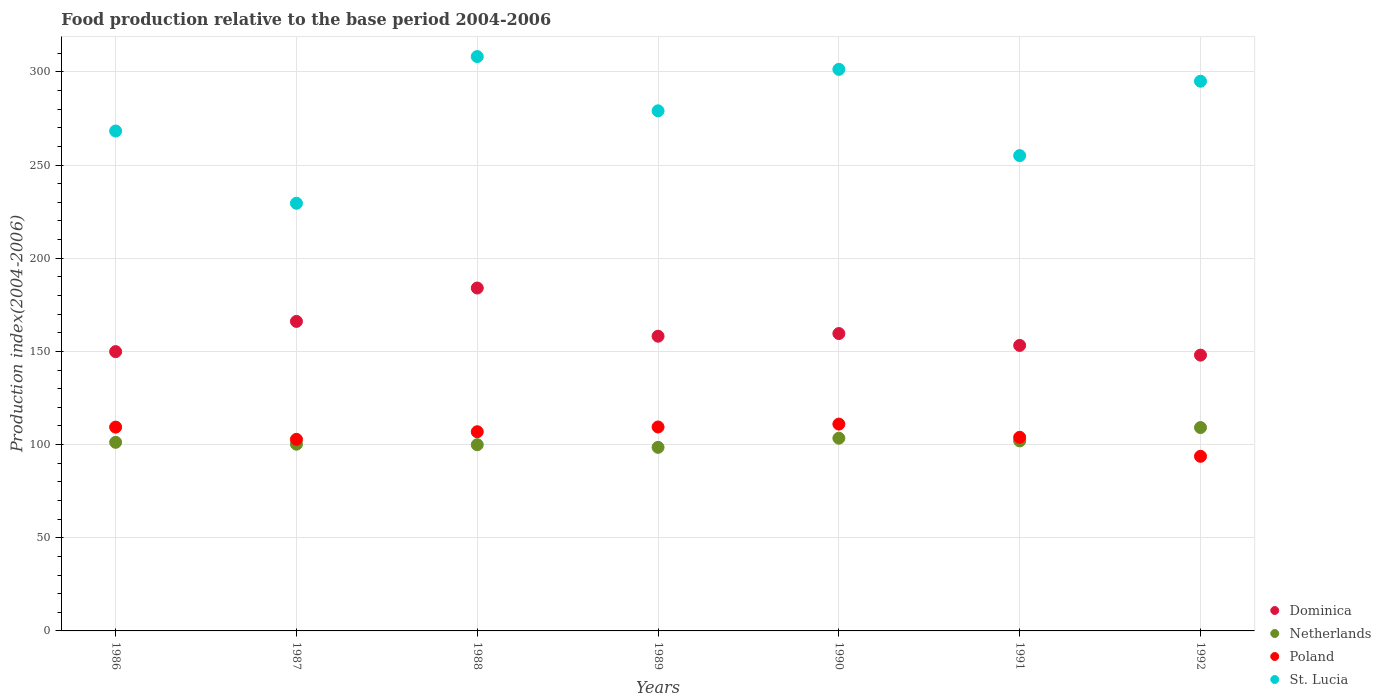How many different coloured dotlines are there?
Ensure brevity in your answer.  4. Is the number of dotlines equal to the number of legend labels?
Ensure brevity in your answer.  Yes. What is the food production index in Poland in 1992?
Offer a terse response. 93.71. Across all years, what is the maximum food production index in Poland?
Your answer should be very brief. 111. Across all years, what is the minimum food production index in Poland?
Offer a very short reply. 93.71. In which year was the food production index in Poland maximum?
Give a very brief answer. 1990. What is the total food production index in Netherlands in the graph?
Provide a succinct answer. 714.45. What is the difference between the food production index in Netherlands in 1989 and that in 1990?
Provide a succinct answer. -4.9. What is the difference between the food production index in Dominica in 1988 and the food production index in Poland in 1989?
Your answer should be very brief. 74.58. What is the average food production index in Netherlands per year?
Provide a short and direct response. 102.06. In the year 1986, what is the difference between the food production index in Poland and food production index in St. Lucia?
Your response must be concise. -158.92. In how many years, is the food production index in Dominica greater than 110?
Your answer should be very brief. 7. What is the ratio of the food production index in Poland in 1989 to that in 1991?
Offer a terse response. 1.05. Is the difference between the food production index in Poland in 1986 and 1988 greater than the difference between the food production index in St. Lucia in 1986 and 1988?
Give a very brief answer. Yes. What is the difference between the highest and the second highest food production index in Dominica?
Offer a terse response. 17.92. What is the difference between the highest and the lowest food production index in Dominica?
Your answer should be compact. 36.01. In how many years, is the food production index in Dominica greater than the average food production index in Dominica taken over all years?
Provide a short and direct response. 2. Is the sum of the food production index in St. Lucia in 1987 and 1991 greater than the maximum food production index in Poland across all years?
Ensure brevity in your answer.  Yes. Is it the case that in every year, the sum of the food production index in Poland and food production index in St. Lucia  is greater than the sum of food production index in Dominica and food production index in Netherlands?
Ensure brevity in your answer.  No. Is the food production index in Dominica strictly greater than the food production index in Netherlands over the years?
Offer a terse response. Yes. Is the food production index in Dominica strictly less than the food production index in St. Lucia over the years?
Your answer should be very brief. Yes. Does the graph contain grids?
Offer a very short reply. Yes. What is the title of the graph?
Provide a succinct answer. Food production relative to the base period 2004-2006. What is the label or title of the X-axis?
Keep it short and to the point. Years. What is the label or title of the Y-axis?
Your response must be concise. Production index(2004-2006). What is the Production index(2004-2006) in Dominica in 1986?
Your response must be concise. 149.89. What is the Production index(2004-2006) in Netherlands in 1986?
Your response must be concise. 101.22. What is the Production index(2004-2006) in Poland in 1986?
Keep it short and to the point. 109.38. What is the Production index(2004-2006) in St. Lucia in 1986?
Your answer should be very brief. 268.3. What is the Production index(2004-2006) of Dominica in 1987?
Your answer should be very brief. 166.11. What is the Production index(2004-2006) of Netherlands in 1987?
Offer a very short reply. 100.22. What is the Production index(2004-2006) of Poland in 1987?
Your response must be concise. 102.81. What is the Production index(2004-2006) in St. Lucia in 1987?
Provide a succinct answer. 229.51. What is the Production index(2004-2006) of Dominica in 1988?
Make the answer very short. 184.03. What is the Production index(2004-2006) in Netherlands in 1988?
Offer a terse response. 99.93. What is the Production index(2004-2006) of Poland in 1988?
Provide a succinct answer. 106.9. What is the Production index(2004-2006) of St. Lucia in 1988?
Your response must be concise. 308.25. What is the Production index(2004-2006) in Dominica in 1989?
Keep it short and to the point. 158.17. What is the Production index(2004-2006) in Netherlands in 1989?
Make the answer very short. 98.53. What is the Production index(2004-2006) in Poland in 1989?
Your answer should be compact. 109.45. What is the Production index(2004-2006) in St. Lucia in 1989?
Offer a terse response. 279.13. What is the Production index(2004-2006) in Dominica in 1990?
Give a very brief answer. 159.59. What is the Production index(2004-2006) in Netherlands in 1990?
Your answer should be very brief. 103.43. What is the Production index(2004-2006) of Poland in 1990?
Make the answer very short. 111. What is the Production index(2004-2006) of St. Lucia in 1990?
Offer a very short reply. 301.38. What is the Production index(2004-2006) of Dominica in 1991?
Ensure brevity in your answer.  153.22. What is the Production index(2004-2006) in Netherlands in 1991?
Ensure brevity in your answer.  101.98. What is the Production index(2004-2006) of Poland in 1991?
Ensure brevity in your answer.  103.91. What is the Production index(2004-2006) in St. Lucia in 1991?
Offer a very short reply. 255.09. What is the Production index(2004-2006) in Dominica in 1992?
Offer a terse response. 148.02. What is the Production index(2004-2006) of Netherlands in 1992?
Provide a short and direct response. 109.14. What is the Production index(2004-2006) of Poland in 1992?
Your response must be concise. 93.71. What is the Production index(2004-2006) of St. Lucia in 1992?
Your response must be concise. 295.02. Across all years, what is the maximum Production index(2004-2006) of Dominica?
Keep it short and to the point. 184.03. Across all years, what is the maximum Production index(2004-2006) of Netherlands?
Provide a succinct answer. 109.14. Across all years, what is the maximum Production index(2004-2006) in Poland?
Your answer should be compact. 111. Across all years, what is the maximum Production index(2004-2006) in St. Lucia?
Offer a terse response. 308.25. Across all years, what is the minimum Production index(2004-2006) of Dominica?
Your response must be concise. 148.02. Across all years, what is the minimum Production index(2004-2006) of Netherlands?
Offer a very short reply. 98.53. Across all years, what is the minimum Production index(2004-2006) of Poland?
Keep it short and to the point. 93.71. Across all years, what is the minimum Production index(2004-2006) of St. Lucia?
Provide a short and direct response. 229.51. What is the total Production index(2004-2006) in Dominica in the graph?
Ensure brevity in your answer.  1119.03. What is the total Production index(2004-2006) in Netherlands in the graph?
Make the answer very short. 714.45. What is the total Production index(2004-2006) of Poland in the graph?
Keep it short and to the point. 737.16. What is the total Production index(2004-2006) of St. Lucia in the graph?
Your answer should be compact. 1936.68. What is the difference between the Production index(2004-2006) in Dominica in 1986 and that in 1987?
Provide a short and direct response. -16.22. What is the difference between the Production index(2004-2006) of Netherlands in 1986 and that in 1987?
Provide a succinct answer. 1. What is the difference between the Production index(2004-2006) in Poland in 1986 and that in 1987?
Provide a short and direct response. 6.57. What is the difference between the Production index(2004-2006) of St. Lucia in 1986 and that in 1987?
Provide a short and direct response. 38.79. What is the difference between the Production index(2004-2006) of Dominica in 1986 and that in 1988?
Provide a succinct answer. -34.14. What is the difference between the Production index(2004-2006) in Netherlands in 1986 and that in 1988?
Provide a succinct answer. 1.29. What is the difference between the Production index(2004-2006) in Poland in 1986 and that in 1988?
Your answer should be very brief. 2.48. What is the difference between the Production index(2004-2006) in St. Lucia in 1986 and that in 1988?
Your answer should be compact. -39.95. What is the difference between the Production index(2004-2006) in Dominica in 1986 and that in 1989?
Provide a succinct answer. -8.28. What is the difference between the Production index(2004-2006) of Netherlands in 1986 and that in 1989?
Offer a terse response. 2.69. What is the difference between the Production index(2004-2006) in Poland in 1986 and that in 1989?
Provide a short and direct response. -0.07. What is the difference between the Production index(2004-2006) in St. Lucia in 1986 and that in 1989?
Offer a very short reply. -10.83. What is the difference between the Production index(2004-2006) of Netherlands in 1986 and that in 1990?
Offer a very short reply. -2.21. What is the difference between the Production index(2004-2006) of Poland in 1986 and that in 1990?
Offer a very short reply. -1.62. What is the difference between the Production index(2004-2006) of St. Lucia in 1986 and that in 1990?
Ensure brevity in your answer.  -33.08. What is the difference between the Production index(2004-2006) of Dominica in 1986 and that in 1991?
Provide a short and direct response. -3.33. What is the difference between the Production index(2004-2006) in Netherlands in 1986 and that in 1991?
Your response must be concise. -0.76. What is the difference between the Production index(2004-2006) of Poland in 1986 and that in 1991?
Provide a succinct answer. 5.47. What is the difference between the Production index(2004-2006) in St. Lucia in 1986 and that in 1991?
Your response must be concise. 13.21. What is the difference between the Production index(2004-2006) of Dominica in 1986 and that in 1992?
Provide a short and direct response. 1.87. What is the difference between the Production index(2004-2006) in Netherlands in 1986 and that in 1992?
Keep it short and to the point. -7.92. What is the difference between the Production index(2004-2006) of Poland in 1986 and that in 1992?
Give a very brief answer. 15.67. What is the difference between the Production index(2004-2006) in St. Lucia in 1986 and that in 1992?
Your answer should be compact. -26.72. What is the difference between the Production index(2004-2006) in Dominica in 1987 and that in 1988?
Make the answer very short. -17.92. What is the difference between the Production index(2004-2006) in Netherlands in 1987 and that in 1988?
Your answer should be compact. 0.29. What is the difference between the Production index(2004-2006) of Poland in 1987 and that in 1988?
Offer a very short reply. -4.09. What is the difference between the Production index(2004-2006) in St. Lucia in 1987 and that in 1988?
Make the answer very short. -78.74. What is the difference between the Production index(2004-2006) of Dominica in 1987 and that in 1989?
Your answer should be compact. 7.94. What is the difference between the Production index(2004-2006) of Netherlands in 1987 and that in 1989?
Give a very brief answer. 1.69. What is the difference between the Production index(2004-2006) of Poland in 1987 and that in 1989?
Your answer should be compact. -6.64. What is the difference between the Production index(2004-2006) of St. Lucia in 1987 and that in 1989?
Your answer should be compact. -49.62. What is the difference between the Production index(2004-2006) of Dominica in 1987 and that in 1990?
Provide a succinct answer. 6.52. What is the difference between the Production index(2004-2006) of Netherlands in 1987 and that in 1990?
Offer a terse response. -3.21. What is the difference between the Production index(2004-2006) in Poland in 1987 and that in 1990?
Provide a succinct answer. -8.19. What is the difference between the Production index(2004-2006) in St. Lucia in 1987 and that in 1990?
Offer a very short reply. -71.87. What is the difference between the Production index(2004-2006) in Dominica in 1987 and that in 1991?
Provide a succinct answer. 12.89. What is the difference between the Production index(2004-2006) of Netherlands in 1987 and that in 1991?
Ensure brevity in your answer.  -1.76. What is the difference between the Production index(2004-2006) of St. Lucia in 1987 and that in 1991?
Keep it short and to the point. -25.58. What is the difference between the Production index(2004-2006) of Dominica in 1987 and that in 1992?
Offer a terse response. 18.09. What is the difference between the Production index(2004-2006) in Netherlands in 1987 and that in 1992?
Offer a very short reply. -8.92. What is the difference between the Production index(2004-2006) in St. Lucia in 1987 and that in 1992?
Provide a short and direct response. -65.51. What is the difference between the Production index(2004-2006) of Dominica in 1988 and that in 1989?
Your response must be concise. 25.86. What is the difference between the Production index(2004-2006) in Poland in 1988 and that in 1989?
Ensure brevity in your answer.  -2.55. What is the difference between the Production index(2004-2006) of St. Lucia in 1988 and that in 1989?
Make the answer very short. 29.12. What is the difference between the Production index(2004-2006) in Dominica in 1988 and that in 1990?
Give a very brief answer. 24.44. What is the difference between the Production index(2004-2006) in Netherlands in 1988 and that in 1990?
Make the answer very short. -3.5. What is the difference between the Production index(2004-2006) in Poland in 1988 and that in 1990?
Offer a terse response. -4.1. What is the difference between the Production index(2004-2006) of St. Lucia in 1988 and that in 1990?
Your response must be concise. 6.87. What is the difference between the Production index(2004-2006) in Dominica in 1988 and that in 1991?
Offer a terse response. 30.81. What is the difference between the Production index(2004-2006) in Netherlands in 1988 and that in 1991?
Your answer should be compact. -2.05. What is the difference between the Production index(2004-2006) in Poland in 1988 and that in 1991?
Your answer should be compact. 2.99. What is the difference between the Production index(2004-2006) of St. Lucia in 1988 and that in 1991?
Make the answer very short. 53.16. What is the difference between the Production index(2004-2006) of Dominica in 1988 and that in 1992?
Ensure brevity in your answer.  36.01. What is the difference between the Production index(2004-2006) of Netherlands in 1988 and that in 1992?
Ensure brevity in your answer.  -9.21. What is the difference between the Production index(2004-2006) in Poland in 1988 and that in 1992?
Your answer should be compact. 13.19. What is the difference between the Production index(2004-2006) in St. Lucia in 1988 and that in 1992?
Provide a succinct answer. 13.23. What is the difference between the Production index(2004-2006) of Dominica in 1989 and that in 1990?
Your answer should be very brief. -1.42. What is the difference between the Production index(2004-2006) of Poland in 1989 and that in 1990?
Your response must be concise. -1.55. What is the difference between the Production index(2004-2006) in St. Lucia in 1989 and that in 1990?
Your answer should be compact. -22.25. What is the difference between the Production index(2004-2006) of Dominica in 1989 and that in 1991?
Give a very brief answer. 4.95. What is the difference between the Production index(2004-2006) in Netherlands in 1989 and that in 1991?
Give a very brief answer. -3.45. What is the difference between the Production index(2004-2006) of Poland in 1989 and that in 1991?
Offer a very short reply. 5.54. What is the difference between the Production index(2004-2006) in St. Lucia in 1989 and that in 1991?
Offer a very short reply. 24.04. What is the difference between the Production index(2004-2006) of Dominica in 1989 and that in 1992?
Keep it short and to the point. 10.15. What is the difference between the Production index(2004-2006) in Netherlands in 1989 and that in 1992?
Your answer should be compact. -10.61. What is the difference between the Production index(2004-2006) in Poland in 1989 and that in 1992?
Your response must be concise. 15.74. What is the difference between the Production index(2004-2006) in St. Lucia in 1989 and that in 1992?
Provide a short and direct response. -15.89. What is the difference between the Production index(2004-2006) of Dominica in 1990 and that in 1991?
Your response must be concise. 6.37. What is the difference between the Production index(2004-2006) of Netherlands in 1990 and that in 1991?
Give a very brief answer. 1.45. What is the difference between the Production index(2004-2006) in Poland in 1990 and that in 1991?
Offer a very short reply. 7.09. What is the difference between the Production index(2004-2006) of St. Lucia in 1990 and that in 1991?
Make the answer very short. 46.29. What is the difference between the Production index(2004-2006) of Dominica in 1990 and that in 1992?
Ensure brevity in your answer.  11.57. What is the difference between the Production index(2004-2006) of Netherlands in 1990 and that in 1992?
Your answer should be compact. -5.71. What is the difference between the Production index(2004-2006) of Poland in 1990 and that in 1992?
Offer a very short reply. 17.29. What is the difference between the Production index(2004-2006) of St. Lucia in 1990 and that in 1992?
Ensure brevity in your answer.  6.36. What is the difference between the Production index(2004-2006) of Netherlands in 1991 and that in 1992?
Keep it short and to the point. -7.16. What is the difference between the Production index(2004-2006) of Poland in 1991 and that in 1992?
Your answer should be compact. 10.2. What is the difference between the Production index(2004-2006) of St. Lucia in 1991 and that in 1992?
Make the answer very short. -39.93. What is the difference between the Production index(2004-2006) in Dominica in 1986 and the Production index(2004-2006) in Netherlands in 1987?
Give a very brief answer. 49.67. What is the difference between the Production index(2004-2006) in Dominica in 1986 and the Production index(2004-2006) in Poland in 1987?
Your answer should be compact. 47.08. What is the difference between the Production index(2004-2006) of Dominica in 1986 and the Production index(2004-2006) of St. Lucia in 1987?
Your answer should be very brief. -79.62. What is the difference between the Production index(2004-2006) in Netherlands in 1986 and the Production index(2004-2006) in Poland in 1987?
Offer a very short reply. -1.59. What is the difference between the Production index(2004-2006) of Netherlands in 1986 and the Production index(2004-2006) of St. Lucia in 1987?
Offer a very short reply. -128.29. What is the difference between the Production index(2004-2006) of Poland in 1986 and the Production index(2004-2006) of St. Lucia in 1987?
Offer a very short reply. -120.13. What is the difference between the Production index(2004-2006) of Dominica in 1986 and the Production index(2004-2006) of Netherlands in 1988?
Your answer should be compact. 49.96. What is the difference between the Production index(2004-2006) of Dominica in 1986 and the Production index(2004-2006) of Poland in 1988?
Give a very brief answer. 42.99. What is the difference between the Production index(2004-2006) of Dominica in 1986 and the Production index(2004-2006) of St. Lucia in 1988?
Keep it short and to the point. -158.36. What is the difference between the Production index(2004-2006) in Netherlands in 1986 and the Production index(2004-2006) in Poland in 1988?
Give a very brief answer. -5.68. What is the difference between the Production index(2004-2006) of Netherlands in 1986 and the Production index(2004-2006) of St. Lucia in 1988?
Your answer should be compact. -207.03. What is the difference between the Production index(2004-2006) of Poland in 1986 and the Production index(2004-2006) of St. Lucia in 1988?
Offer a terse response. -198.87. What is the difference between the Production index(2004-2006) in Dominica in 1986 and the Production index(2004-2006) in Netherlands in 1989?
Offer a very short reply. 51.36. What is the difference between the Production index(2004-2006) of Dominica in 1986 and the Production index(2004-2006) of Poland in 1989?
Offer a very short reply. 40.44. What is the difference between the Production index(2004-2006) in Dominica in 1986 and the Production index(2004-2006) in St. Lucia in 1989?
Keep it short and to the point. -129.24. What is the difference between the Production index(2004-2006) in Netherlands in 1986 and the Production index(2004-2006) in Poland in 1989?
Offer a very short reply. -8.23. What is the difference between the Production index(2004-2006) in Netherlands in 1986 and the Production index(2004-2006) in St. Lucia in 1989?
Your response must be concise. -177.91. What is the difference between the Production index(2004-2006) in Poland in 1986 and the Production index(2004-2006) in St. Lucia in 1989?
Your response must be concise. -169.75. What is the difference between the Production index(2004-2006) of Dominica in 1986 and the Production index(2004-2006) of Netherlands in 1990?
Your answer should be compact. 46.46. What is the difference between the Production index(2004-2006) of Dominica in 1986 and the Production index(2004-2006) of Poland in 1990?
Your response must be concise. 38.89. What is the difference between the Production index(2004-2006) in Dominica in 1986 and the Production index(2004-2006) in St. Lucia in 1990?
Your response must be concise. -151.49. What is the difference between the Production index(2004-2006) in Netherlands in 1986 and the Production index(2004-2006) in Poland in 1990?
Offer a very short reply. -9.78. What is the difference between the Production index(2004-2006) in Netherlands in 1986 and the Production index(2004-2006) in St. Lucia in 1990?
Provide a short and direct response. -200.16. What is the difference between the Production index(2004-2006) of Poland in 1986 and the Production index(2004-2006) of St. Lucia in 1990?
Your response must be concise. -192. What is the difference between the Production index(2004-2006) in Dominica in 1986 and the Production index(2004-2006) in Netherlands in 1991?
Your response must be concise. 47.91. What is the difference between the Production index(2004-2006) of Dominica in 1986 and the Production index(2004-2006) of Poland in 1991?
Offer a terse response. 45.98. What is the difference between the Production index(2004-2006) in Dominica in 1986 and the Production index(2004-2006) in St. Lucia in 1991?
Offer a terse response. -105.2. What is the difference between the Production index(2004-2006) in Netherlands in 1986 and the Production index(2004-2006) in Poland in 1991?
Your response must be concise. -2.69. What is the difference between the Production index(2004-2006) in Netherlands in 1986 and the Production index(2004-2006) in St. Lucia in 1991?
Ensure brevity in your answer.  -153.87. What is the difference between the Production index(2004-2006) of Poland in 1986 and the Production index(2004-2006) of St. Lucia in 1991?
Your response must be concise. -145.71. What is the difference between the Production index(2004-2006) of Dominica in 1986 and the Production index(2004-2006) of Netherlands in 1992?
Provide a succinct answer. 40.75. What is the difference between the Production index(2004-2006) in Dominica in 1986 and the Production index(2004-2006) in Poland in 1992?
Your answer should be compact. 56.18. What is the difference between the Production index(2004-2006) in Dominica in 1986 and the Production index(2004-2006) in St. Lucia in 1992?
Offer a terse response. -145.13. What is the difference between the Production index(2004-2006) in Netherlands in 1986 and the Production index(2004-2006) in Poland in 1992?
Keep it short and to the point. 7.51. What is the difference between the Production index(2004-2006) of Netherlands in 1986 and the Production index(2004-2006) of St. Lucia in 1992?
Keep it short and to the point. -193.8. What is the difference between the Production index(2004-2006) of Poland in 1986 and the Production index(2004-2006) of St. Lucia in 1992?
Your answer should be compact. -185.64. What is the difference between the Production index(2004-2006) of Dominica in 1987 and the Production index(2004-2006) of Netherlands in 1988?
Offer a terse response. 66.18. What is the difference between the Production index(2004-2006) in Dominica in 1987 and the Production index(2004-2006) in Poland in 1988?
Your answer should be compact. 59.21. What is the difference between the Production index(2004-2006) of Dominica in 1987 and the Production index(2004-2006) of St. Lucia in 1988?
Provide a short and direct response. -142.14. What is the difference between the Production index(2004-2006) in Netherlands in 1987 and the Production index(2004-2006) in Poland in 1988?
Your answer should be very brief. -6.68. What is the difference between the Production index(2004-2006) of Netherlands in 1987 and the Production index(2004-2006) of St. Lucia in 1988?
Provide a succinct answer. -208.03. What is the difference between the Production index(2004-2006) in Poland in 1987 and the Production index(2004-2006) in St. Lucia in 1988?
Your answer should be very brief. -205.44. What is the difference between the Production index(2004-2006) in Dominica in 1987 and the Production index(2004-2006) in Netherlands in 1989?
Your response must be concise. 67.58. What is the difference between the Production index(2004-2006) in Dominica in 1987 and the Production index(2004-2006) in Poland in 1989?
Keep it short and to the point. 56.66. What is the difference between the Production index(2004-2006) of Dominica in 1987 and the Production index(2004-2006) of St. Lucia in 1989?
Provide a succinct answer. -113.02. What is the difference between the Production index(2004-2006) in Netherlands in 1987 and the Production index(2004-2006) in Poland in 1989?
Offer a very short reply. -9.23. What is the difference between the Production index(2004-2006) of Netherlands in 1987 and the Production index(2004-2006) of St. Lucia in 1989?
Give a very brief answer. -178.91. What is the difference between the Production index(2004-2006) of Poland in 1987 and the Production index(2004-2006) of St. Lucia in 1989?
Keep it short and to the point. -176.32. What is the difference between the Production index(2004-2006) of Dominica in 1987 and the Production index(2004-2006) of Netherlands in 1990?
Provide a succinct answer. 62.68. What is the difference between the Production index(2004-2006) of Dominica in 1987 and the Production index(2004-2006) of Poland in 1990?
Keep it short and to the point. 55.11. What is the difference between the Production index(2004-2006) of Dominica in 1987 and the Production index(2004-2006) of St. Lucia in 1990?
Your response must be concise. -135.27. What is the difference between the Production index(2004-2006) in Netherlands in 1987 and the Production index(2004-2006) in Poland in 1990?
Provide a succinct answer. -10.78. What is the difference between the Production index(2004-2006) of Netherlands in 1987 and the Production index(2004-2006) of St. Lucia in 1990?
Offer a very short reply. -201.16. What is the difference between the Production index(2004-2006) in Poland in 1987 and the Production index(2004-2006) in St. Lucia in 1990?
Offer a terse response. -198.57. What is the difference between the Production index(2004-2006) of Dominica in 1987 and the Production index(2004-2006) of Netherlands in 1991?
Offer a very short reply. 64.13. What is the difference between the Production index(2004-2006) of Dominica in 1987 and the Production index(2004-2006) of Poland in 1991?
Your response must be concise. 62.2. What is the difference between the Production index(2004-2006) of Dominica in 1987 and the Production index(2004-2006) of St. Lucia in 1991?
Your answer should be compact. -88.98. What is the difference between the Production index(2004-2006) in Netherlands in 1987 and the Production index(2004-2006) in Poland in 1991?
Provide a succinct answer. -3.69. What is the difference between the Production index(2004-2006) in Netherlands in 1987 and the Production index(2004-2006) in St. Lucia in 1991?
Provide a short and direct response. -154.87. What is the difference between the Production index(2004-2006) of Poland in 1987 and the Production index(2004-2006) of St. Lucia in 1991?
Keep it short and to the point. -152.28. What is the difference between the Production index(2004-2006) of Dominica in 1987 and the Production index(2004-2006) of Netherlands in 1992?
Your response must be concise. 56.97. What is the difference between the Production index(2004-2006) in Dominica in 1987 and the Production index(2004-2006) in Poland in 1992?
Give a very brief answer. 72.4. What is the difference between the Production index(2004-2006) of Dominica in 1987 and the Production index(2004-2006) of St. Lucia in 1992?
Your response must be concise. -128.91. What is the difference between the Production index(2004-2006) of Netherlands in 1987 and the Production index(2004-2006) of Poland in 1992?
Offer a terse response. 6.51. What is the difference between the Production index(2004-2006) of Netherlands in 1987 and the Production index(2004-2006) of St. Lucia in 1992?
Your answer should be compact. -194.8. What is the difference between the Production index(2004-2006) of Poland in 1987 and the Production index(2004-2006) of St. Lucia in 1992?
Provide a short and direct response. -192.21. What is the difference between the Production index(2004-2006) of Dominica in 1988 and the Production index(2004-2006) of Netherlands in 1989?
Offer a terse response. 85.5. What is the difference between the Production index(2004-2006) in Dominica in 1988 and the Production index(2004-2006) in Poland in 1989?
Provide a succinct answer. 74.58. What is the difference between the Production index(2004-2006) in Dominica in 1988 and the Production index(2004-2006) in St. Lucia in 1989?
Provide a succinct answer. -95.1. What is the difference between the Production index(2004-2006) of Netherlands in 1988 and the Production index(2004-2006) of Poland in 1989?
Give a very brief answer. -9.52. What is the difference between the Production index(2004-2006) of Netherlands in 1988 and the Production index(2004-2006) of St. Lucia in 1989?
Make the answer very short. -179.2. What is the difference between the Production index(2004-2006) of Poland in 1988 and the Production index(2004-2006) of St. Lucia in 1989?
Provide a short and direct response. -172.23. What is the difference between the Production index(2004-2006) of Dominica in 1988 and the Production index(2004-2006) of Netherlands in 1990?
Ensure brevity in your answer.  80.6. What is the difference between the Production index(2004-2006) of Dominica in 1988 and the Production index(2004-2006) of Poland in 1990?
Give a very brief answer. 73.03. What is the difference between the Production index(2004-2006) in Dominica in 1988 and the Production index(2004-2006) in St. Lucia in 1990?
Offer a terse response. -117.35. What is the difference between the Production index(2004-2006) of Netherlands in 1988 and the Production index(2004-2006) of Poland in 1990?
Offer a very short reply. -11.07. What is the difference between the Production index(2004-2006) in Netherlands in 1988 and the Production index(2004-2006) in St. Lucia in 1990?
Offer a terse response. -201.45. What is the difference between the Production index(2004-2006) of Poland in 1988 and the Production index(2004-2006) of St. Lucia in 1990?
Keep it short and to the point. -194.48. What is the difference between the Production index(2004-2006) in Dominica in 1988 and the Production index(2004-2006) in Netherlands in 1991?
Offer a very short reply. 82.05. What is the difference between the Production index(2004-2006) of Dominica in 1988 and the Production index(2004-2006) of Poland in 1991?
Ensure brevity in your answer.  80.12. What is the difference between the Production index(2004-2006) in Dominica in 1988 and the Production index(2004-2006) in St. Lucia in 1991?
Keep it short and to the point. -71.06. What is the difference between the Production index(2004-2006) of Netherlands in 1988 and the Production index(2004-2006) of Poland in 1991?
Offer a very short reply. -3.98. What is the difference between the Production index(2004-2006) of Netherlands in 1988 and the Production index(2004-2006) of St. Lucia in 1991?
Keep it short and to the point. -155.16. What is the difference between the Production index(2004-2006) in Poland in 1988 and the Production index(2004-2006) in St. Lucia in 1991?
Your answer should be very brief. -148.19. What is the difference between the Production index(2004-2006) in Dominica in 1988 and the Production index(2004-2006) in Netherlands in 1992?
Your response must be concise. 74.89. What is the difference between the Production index(2004-2006) in Dominica in 1988 and the Production index(2004-2006) in Poland in 1992?
Ensure brevity in your answer.  90.32. What is the difference between the Production index(2004-2006) in Dominica in 1988 and the Production index(2004-2006) in St. Lucia in 1992?
Offer a very short reply. -110.99. What is the difference between the Production index(2004-2006) of Netherlands in 1988 and the Production index(2004-2006) of Poland in 1992?
Your answer should be very brief. 6.22. What is the difference between the Production index(2004-2006) of Netherlands in 1988 and the Production index(2004-2006) of St. Lucia in 1992?
Offer a terse response. -195.09. What is the difference between the Production index(2004-2006) in Poland in 1988 and the Production index(2004-2006) in St. Lucia in 1992?
Ensure brevity in your answer.  -188.12. What is the difference between the Production index(2004-2006) of Dominica in 1989 and the Production index(2004-2006) of Netherlands in 1990?
Provide a short and direct response. 54.74. What is the difference between the Production index(2004-2006) of Dominica in 1989 and the Production index(2004-2006) of Poland in 1990?
Provide a short and direct response. 47.17. What is the difference between the Production index(2004-2006) of Dominica in 1989 and the Production index(2004-2006) of St. Lucia in 1990?
Give a very brief answer. -143.21. What is the difference between the Production index(2004-2006) in Netherlands in 1989 and the Production index(2004-2006) in Poland in 1990?
Ensure brevity in your answer.  -12.47. What is the difference between the Production index(2004-2006) of Netherlands in 1989 and the Production index(2004-2006) of St. Lucia in 1990?
Provide a succinct answer. -202.85. What is the difference between the Production index(2004-2006) in Poland in 1989 and the Production index(2004-2006) in St. Lucia in 1990?
Provide a succinct answer. -191.93. What is the difference between the Production index(2004-2006) of Dominica in 1989 and the Production index(2004-2006) of Netherlands in 1991?
Give a very brief answer. 56.19. What is the difference between the Production index(2004-2006) in Dominica in 1989 and the Production index(2004-2006) in Poland in 1991?
Keep it short and to the point. 54.26. What is the difference between the Production index(2004-2006) of Dominica in 1989 and the Production index(2004-2006) of St. Lucia in 1991?
Give a very brief answer. -96.92. What is the difference between the Production index(2004-2006) in Netherlands in 1989 and the Production index(2004-2006) in Poland in 1991?
Make the answer very short. -5.38. What is the difference between the Production index(2004-2006) of Netherlands in 1989 and the Production index(2004-2006) of St. Lucia in 1991?
Your answer should be compact. -156.56. What is the difference between the Production index(2004-2006) of Poland in 1989 and the Production index(2004-2006) of St. Lucia in 1991?
Provide a short and direct response. -145.64. What is the difference between the Production index(2004-2006) of Dominica in 1989 and the Production index(2004-2006) of Netherlands in 1992?
Your answer should be compact. 49.03. What is the difference between the Production index(2004-2006) in Dominica in 1989 and the Production index(2004-2006) in Poland in 1992?
Offer a terse response. 64.46. What is the difference between the Production index(2004-2006) of Dominica in 1989 and the Production index(2004-2006) of St. Lucia in 1992?
Give a very brief answer. -136.85. What is the difference between the Production index(2004-2006) of Netherlands in 1989 and the Production index(2004-2006) of Poland in 1992?
Give a very brief answer. 4.82. What is the difference between the Production index(2004-2006) of Netherlands in 1989 and the Production index(2004-2006) of St. Lucia in 1992?
Provide a short and direct response. -196.49. What is the difference between the Production index(2004-2006) of Poland in 1989 and the Production index(2004-2006) of St. Lucia in 1992?
Ensure brevity in your answer.  -185.57. What is the difference between the Production index(2004-2006) in Dominica in 1990 and the Production index(2004-2006) in Netherlands in 1991?
Your answer should be compact. 57.61. What is the difference between the Production index(2004-2006) in Dominica in 1990 and the Production index(2004-2006) in Poland in 1991?
Keep it short and to the point. 55.68. What is the difference between the Production index(2004-2006) of Dominica in 1990 and the Production index(2004-2006) of St. Lucia in 1991?
Provide a short and direct response. -95.5. What is the difference between the Production index(2004-2006) in Netherlands in 1990 and the Production index(2004-2006) in Poland in 1991?
Your answer should be very brief. -0.48. What is the difference between the Production index(2004-2006) in Netherlands in 1990 and the Production index(2004-2006) in St. Lucia in 1991?
Your response must be concise. -151.66. What is the difference between the Production index(2004-2006) of Poland in 1990 and the Production index(2004-2006) of St. Lucia in 1991?
Provide a short and direct response. -144.09. What is the difference between the Production index(2004-2006) of Dominica in 1990 and the Production index(2004-2006) of Netherlands in 1992?
Offer a terse response. 50.45. What is the difference between the Production index(2004-2006) in Dominica in 1990 and the Production index(2004-2006) in Poland in 1992?
Provide a succinct answer. 65.88. What is the difference between the Production index(2004-2006) in Dominica in 1990 and the Production index(2004-2006) in St. Lucia in 1992?
Offer a very short reply. -135.43. What is the difference between the Production index(2004-2006) of Netherlands in 1990 and the Production index(2004-2006) of Poland in 1992?
Your answer should be compact. 9.72. What is the difference between the Production index(2004-2006) in Netherlands in 1990 and the Production index(2004-2006) in St. Lucia in 1992?
Your response must be concise. -191.59. What is the difference between the Production index(2004-2006) of Poland in 1990 and the Production index(2004-2006) of St. Lucia in 1992?
Provide a succinct answer. -184.02. What is the difference between the Production index(2004-2006) of Dominica in 1991 and the Production index(2004-2006) of Netherlands in 1992?
Give a very brief answer. 44.08. What is the difference between the Production index(2004-2006) of Dominica in 1991 and the Production index(2004-2006) of Poland in 1992?
Keep it short and to the point. 59.51. What is the difference between the Production index(2004-2006) in Dominica in 1991 and the Production index(2004-2006) in St. Lucia in 1992?
Your answer should be very brief. -141.8. What is the difference between the Production index(2004-2006) in Netherlands in 1991 and the Production index(2004-2006) in Poland in 1992?
Your response must be concise. 8.27. What is the difference between the Production index(2004-2006) of Netherlands in 1991 and the Production index(2004-2006) of St. Lucia in 1992?
Provide a succinct answer. -193.04. What is the difference between the Production index(2004-2006) in Poland in 1991 and the Production index(2004-2006) in St. Lucia in 1992?
Offer a terse response. -191.11. What is the average Production index(2004-2006) in Dominica per year?
Your answer should be compact. 159.86. What is the average Production index(2004-2006) in Netherlands per year?
Make the answer very short. 102.06. What is the average Production index(2004-2006) of Poland per year?
Ensure brevity in your answer.  105.31. What is the average Production index(2004-2006) of St. Lucia per year?
Provide a succinct answer. 276.67. In the year 1986, what is the difference between the Production index(2004-2006) in Dominica and Production index(2004-2006) in Netherlands?
Offer a terse response. 48.67. In the year 1986, what is the difference between the Production index(2004-2006) in Dominica and Production index(2004-2006) in Poland?
Provide a succinct answer. 40.51. In the year 1986, what is the difference between the Production index(2004-2006) of Dominica and Production index(2004-2006) of St. Lucia?
Keep it short and to the point. -118.41. In the year 1986, what is the difference between the Production index(2004-2006) of Netherlands and Production index(2004-2006) of Poland?
Provide a succinct answer. -8.16. In the year 1986, what is the difference between the Production index(2004-2006) in Netherlands and Production index(2004-2006) in St. Lucia?
Your answer should be very brief. -167.08. In the year 1986, what is the difference between the Production index(2004-2006) in Poland and Production index(2004-2006) in St. Lucia?
Provide a short and direct response. -158.92. In the year 1987, what is the difference between the Production index(2004-2006) in Dominica and Production index(2004-2006) in Netherlands?
Provide a short and direct response. 65.89. In the year 1987, what is the difference between the Production index(2004-2006) of Dominica and Production index(2004-2006) of Poland?
Make the answer very short. 63.3. In the year 1987, what is the difference between the Production index(2004-2006) of Dominica and Production index(2004-2006) of St. Lucia?
Your response must be concise. -63.4. In the year 1987, what is the difference between the Production index(2004-2006) of Netherlands and Production index(2004-2006) of Poland?
Keep it short and to the point. -2.59. In the year 1987, what is the difference between the Production index(2004-2006) of Netherlands and Production index(2004-2006) of St. Lucia?
Provide a short and direct response. -129.29. In the year 1987, what is the difference between the Production index(2004-2006) in Poland and Production index(2004-2006) in St. Lucia?
Your answer should be very brief. -126.7. In the year 1988, what is the difference between the Production index(2004-2006) of Dominica and Production index(2004-2006) of Netherlands?
Offer a very short reply. 84.1. In the year 1988, what is the difference between the Production index(2004-2006) of Dominica and Production index(2004-2006) of Poland?
Offer a very short reply. 77.13. In the year 1988, what is the difference between the Production index(2004-2006) of Dominica and Production index(2004-2006) of St. Lucia?
Make the answer very short. -124.22. In the year 1988, what is the difference between the Production index(2004-2006) of Netherlands and Production index(2004-2006) of Poland?
Provide a succinct answer. -6.97. In the year 1988, what is the difference between the Production index(2004-2006) of Netherlands and Production index(2004-2006) of St. Lucia?
Keep it short and to the point. -208.32. In the year 1988, what is the difference between the Production index(2004-2006) of Poland and Production index(2004-2006) of St. Lucia?
Provide a short and direct response. -201.35. In the year 1989, what is the difference between the Production index(2004-2006) of Dominica and Production index(2004-2006) of Netherlands?
Keep it short and to the point. 59.64. In the year 1989, what is the difference between the Production index(2004-2006) in Dominica and Production index(2004-2006) in Poland?
Your answer should be compact. 48.72. In the year 1989, what is the difference between the Production index(2004-2006) of Dominica and Production index(2004-2006) of St. Lucia?
Make the answer very short. -120.96. In the year 1989, what is the difference between the Production index(2004-2006) in Netherlands and Production index(2004-2006) in Poland?
Offer a terse response. -10.92. In the year 1989, what is the difference between the Production index(2004-2006) in Netherlands and Production index(2004-2006) in St. Lucia?
Your answer should be compact. -180.6. In the year 1989, what is the difference between the Production index(2004-2006) of Poland and Production index(2004-2006) of St. Lucia?
Ensure brevity in your answer.  -169.68. In the year 1990, what is the difference between the Production index(2004-2006) in Dominica and Production index(2004-2006) in Netherlands?
Give a very brief answer. 56.16. In the year 1990, what is the difference between the Production index(2004-2006) in Dominica and Production index(2004-2006) in Poland?
Provide a short and direct response. 48.59. In the year 1990, what is the difference between the Production index(2004-2006) of Dominica and Production index(2004-2006) of St. Lucia?
Your answer should be compact. -141.79. In the year 1990, what is the difference between the Production index(2004-2006) of Netherlands and Production index(2004-2006) of Poland?
Your response must be concise. -7.57. In the year 1990, what is the difference between the Production index(2004-2006) in Netherlands and Production index(2004-2006) in St. Lucia?
Your response must be concise. -197.95. In the year 1990, what is the difference between the Production index(2004-2006) in Poland and Production index(2004-2006) in St. Lucia?
Ensure brevity in your answer.  -190.38. In the year 1991, what is the difference between the Production index(2004-2006) in Dominica and Production index(2004-2006) in Netherlands?
Your response must be concise. 51.24. In the year 1991, what is the difference between the Production index(2004-2006) of Dominica and Production index(2004-2006) of Poland?
Keep it short and to the point. 49.31. In the year 1991, what is the difference between the Production index(2004-2006) in Dominica and Production index(2004-2006) in St. Lucia?
Give a very brief answer. -101.87. In the year 1991, what is the difference between the Production index(2004-2006) in Netherlands and Production index(2004-2006) in Poland?
Your answer should be compact. -1.93. In the year 1991, what is the difference between the Production index(2004-2006) in Netherlands and Production index(2004-2006) in St. Lucia?
Offer a very short reply. -153.11. In the year 1991, what is the difference between the Production index(2004-2006) of Poland and Production index(2004-2006) of St. Lucia?
Offer a terse response. -151.18. In the year 1992, what is the difference between the Production index(2004-2006) in Dominica and Production index(2004-2006) in Netherlands?
Give a very brief answer. 38.88. In the year 1992, what is the difference between the Production index(2004-2006) of Dominica and Production index(2004-2006) of Poland?
Give a very brief answer. 54.31. In the year 1992, what is the difference between the Production index(2004-2006) in Dominica and Production index(2004-2006) in St. Lucia?
Your answer should be very brief. -147. In the year 1992, what is the difference between the Production index(2004-2006) of Netherlands and Production index(2004-2006) of Poland?
Provide a short and direct response. 15.43. In the year 1992, what is the difference between the Production index(2004-2006) in Netherlands and Production index(2004-2006) in St. Lucia?
Make the answer very short. -185.88. In the year 1992, what is the difference between the Production index(2004-2006) in Poland and Production index(2004-2006) in St. Lucia?
Offer a very short reply. -201.31. What is the ratio of the Production index(2004-2006) in Dominica in 1986 to that in 1987?
Offer a terse response. 0.9. What is the ratio of the Production index(2004-2006) of Poland in 1986 to that in 1987?
Your answer should be compact. 1.06. What is the ratio of the Production index(2004-2006) in St. Lucia in 1986 to that in 1987?
Keep it short and to the point. 1.17. What is the ratio of the Production index(2004-2006) in Dominica in 1986 to that in 1988?
Your answer should be compact. 0.81. What is the ratio of the Production index(2004-2006) of Netherlands in 1986 to that in 1988?
Provide a short and direct response. 1.01. What is the ratio of the Production index(2004-2006) in Poland in 1986 to that in 1988?
Your response must be concise. 1.02. What is the ratio of the Production index(2004-2006) of St. Lucia in 1986 to that in 1988?
Offer a terse response. 0.87. What is the ratio of the Production index(2004-2006) of Dominica in 1986 to that in 1989?
Your answer should be compact. 0.95. What is the ratio of the Production index(2004-2006) in Netherlands in 1986 to that in 1989?
Provide a short and direct response. 1.03. What is the ratio of the Production index(2004-2006) of Poland in 1986 to that in 1989?
Provide a short and direct response. 1. What is the ratio of the Production index(2004-2006) of St. Lucia in 1986 to that in 1989?
Offer a terse response. 0.96. What is the ratio of the Production index(2004-2006) of Dominica in 1986 to that in 1990?
Provide a succinct answer. 0.94. What is the ratio of the Production index(2004-2006) of Netherlands in 1986 to that in 1990?
Offer a terse response. 0.98. What is the ratio of the Production index(2004-2006) in Poland in 1986 to that in 1990?
Offer a terse response. 0.99. What is the ratio of the Production index(2004-2006) in St. Lucia in 1986 to that in 1990?
Make the answer very short. 0.89. What is the ratio of the Production index(2004-2006) of Dominica in 1986 to that in 1991?
Offer a terse response. 0.98. What is the ratio of the Production index(2004-2006) in Poland in 1986 to that in 1991?
Your answer should be very brief. 1.05. What is the ratio of the Production index(2004-2006) in St. Lucia in 1986 to that in 1991?
Offer a terse response. 1.05. What is the ratio of the Production index(2004-2006) in Dominica in 1986 to that in 1992?
Your answer should be compact. 1.01. What is the ratio of the Production index(2004-2006) of Netherlands in 1986 to that in 1992?
Offer a terse response. 0.93. What is the ratio of the Production index(2004-2006) of Poland in 1986 to that in 1992?
Ensure brevity in your answer.  1.17. What is the ratio of the Production index(2004-2006) in St. Lucia in 1986 to that in 1992?
Offer a terse response. 0.91. What is the ratio of the Production index(2004-2006) in Dominica in 1987 to that in 1988?
Your response must be concise. 0.9. What is the ratio of the Production index(2004-2006) in Netherlands in 1987 to that in 1988?
Give a very brief answer. 1. What is the ratio of the Production index(2004-2006) of Poland in 1987 to that in 1988?
Your answer should be very brief. 0.96. What is the ratio of the Production index(2004-2006) of St. Lucia in 1987 to that in 1988?
Offer a terse response. 0.74. What is the ratio of the Production index(2004-2006) of Dominica in 1987 to that in 1989?
Give a very brief answer. 1.05. What is the ratio of the Production index(2004-2006) of Netherlands in 1987 to that in 1989?
Ensure brevity in your answer.  1.02. What is the ratio of the Production index(2004-2006) of Poland in 1987 to that in 1989?
Your answer should be compact. 0.94. What is the ratio of the Production index(2004-2006) of St. Lucia in 1987 to that in 1989?
Offer a terse response. 0.82. What is the ratio of the Production index(2004-2006) of Dominica in 1987 to that in 1990?
Your response must be concise. 1.04. What is the ratio of the Production index(2004-2006) of Netherlands in 1987 to that in 1990?
Ensure brevity in your answer.  0.97. What is the ratio of the Production index(2004-2006) in Poland in 1987 to that in 1990?
Your answer should be compact. 0.93. What is the ratio of the Production index(2004-2006) in St. Lucia in 1987 to that in 1990?
Ensure brevity in your answer.  0.76. What is the ratio of the Production index(2004-2006) in Dominica in 1987 to that in 1991?
Keep it short and to the point. 1.08. What is the ratio of the Production index(2004-2006) of Netherlands in 1987 to that in 1991?
Provide a short and direct response. 0.98. What is the ratio of the Production index(2004-2006) of St. Lucia in 1987 to that in 1991?
Provide a succinct answer. 0.9. What is the ratio of the Production index(2004-2006) in Dominica in 1987 to that in 1992?
Make the answer very short. 1.12. What is the ratio of the Production index(2004-2006) in Netherlands in 1987 to that in 1992?
Offer a terse response. 0.92. What is the ratio of the Production index(2004-2006) of Poland in 1987 to that in 1992?
Give a very brief answer. 1.1. What is the ratio of the Production index(2004-2006) of St. Lucia in 1987 to that in 1992?
Ensure brevity in your answer.  0.78. What is the ratio of the Production index(2004-2006) of Dominica in 1988 to that in 1989?
Keep it short and to the point. 1.16. What is the ratio of the Production index(2004-2006) of Netherlands in 1988 to that in 1989?
Provide a short and direct response. 1.01. What is the ratio of the Production index(2004-2006) of Poland in 1988 to that in 1989?
Your answer should be very brief. 0.98. What is the ratio of the Production index(2004-2006) of St. Lucia in 1988 to that in 1989?
Provide a succinct answer. 1.1. What is the ratio of the Production index(2004-2006) in Dominica in 1988 to that in 1990?
Your response must be concise. 1.15. What is the ratio of the Production index(2004-2006) of Netherlands in 1988 to that in 1990?
Provide a short and direct response. 0.97. What is the ratio of the Production index(2004-2006) in Poland in 1988 to that in 1990?
Your answer should be compact. 0.96. What is the ratio of the Production index(2004-2006) of St. Lucia in 1988 to that in 1990?
Offer a very short reply. 1.02. What is the ratio of the Production index(2004-2006) in Dominica in 1988 to that in 1991?
Offer a very short reply. 1.2. What is the ratio of the Production index(2004-2006) of Netherlands in 1988 to that in 1991?
Your answer should be very brief. 0.98. What is the ratio of the Production index(2004-2006) in Poland in 1988 to that in 1991?
Your answer should be compact. 1.03. What is the ratio of the Production index(2004-2006) in St. Lucia in 1988 to that in 1991?
Provide a succinct answer. 1.21. What is the ratio of the Production index(2004-2006) in Dominica in 1988 to that in 1992?
Offer a very short reply. 1.24. What is the ratio of the Production index(2004-2006) in Netherlands in 1988 to that in 1992?
Your answer should be very brief. 0.92. What is the ratio of the Production index(2004-2006) of Poland in 1988 to that in 1992?
Your response must be concise. 1.14. What is the ratio of the Production index(2004-2006) in St. Lucia in 1988 to that in 1992?
Make the answer very short. 1.04. What is the ratio of the Production index(2004-2006) in Dominica in 1989 to that in 1990?
Keep it short and to the point. 0.99. What is the ratio of the Production index(2004-2006) of Netherlands in 1989 to that in 1990?
Make the answer very short. 0.95. What is the ratio of the Production index(2004-2006) of Poland in 1989 to that in 1990?
Make the answer very short. 0.99. What is the ratio of the Production index(2004-2006) in St. Lucia in 1989 to that in 1990?
Provide a short and direct response. 0.93. What is the ratio of the Production index(2004-2006) of Dominica in 1989 to that in 1991?
Offer a terse response. 1.03. What is the ratio of the Production index(2004-2006) in Netherlands in 1989 to that in 1991?
Ensure brevity in your answer.  0.97. What is the ratio of the Production index(2004-2006) in Poland in 1989 to that in 1991?
Ensure brevity in your answer.  1.05. What is the ratio of the Production index(2004-2006) in St. Lucia in 1989 to that in 1991?
Make the answer very short. 1.09. What is the ratio of the Production index(2004-2006) in Dominica in 1989 to that in 1992?
Make the answer very short. 1.07. What is the ratio of the Production index(2004-2006) in Netherlands in 1989 to that in 1992?
Your answer should be compact. 0.9. What is the ratio of the Production index(2004-2006) in Poland in 1989 to that in 1992?
Provide a short and direct response. 1.17. What is the ratio of the Production index(2004-2006) of St. Lucia in 1989 to that in 1992?
Ensure brevity in your answer.  0.95. What is the ratio of the Production index(2004-2006) in Dominica in 1990 to that in 1991?
Your answer should be very brief. 1.04. What is the ratio of the Production index(2004-2006) of Netherlands in 1990 to that in 1991?
Provide a short and direct response. 1.01. What is the ratio of the Production index(2004-2006) of Poland in 1990 to that in 1991?
Offer a very short reply. 1.07. What is the ratio of the Production index(2004-2006) in St. Lucia in 1990 to that in 1991?
Your answer should be very brief. 1.18. What is the ratio of the Production index(2004-2006) in Dominica in 1990 to that in 1992?
Give a very brief answer. 1.08. What is the ratio of the Production index(2004-2006) of Netherlands in 1990 to that in 1992?
Ensure brevity in your answer.  0.95. What is the ratio of the Production index(2004-2006) in Poland in 1990 to that in 1992?
Your response must be concise. 1.18. What is the ratio of the Production index(2004-2006) of St. Lucia in 1990 to that in 1992?
Your response must be concise. 1.02. What is the ratio of the Production index(2004-2006) of Dominica in 1991 to that in 1992?
Provide a succinct answer. 1.04. What is the ratio of the Production index(2004-2006) in Netherlands in 1991 to that in 1992?
Provide a succinct answer. 0.93. What is the ratio of the Production index(2004-2006) of Poland in 1991 to that in 1992?
Keep it short and to the point. 1.11. What is the ratio of the Production index(2004-2006) of St. Lucia in 1991 to that in 1992?
Ensure brevity in your answer.  0.86. What is the difference between the highest and the second highest Production index(2004-2006) of Dominica?
Ensure brevity in your answer.  17.92. What is the difference between the highest and the second highest Production index(2004-2006) in Netherlands?
Provide a short and direct response. 5.71. What is the difference between the highest and the second highest Production index(2004-2006) in Poland?
Make the answer very short. 1.55. What is the difference between the highest and the second highest Production index(2004-2006) of St. Lucia?
Provide a short and direct response. 6.87. What is the difference between the highest and the lowest Production index(2004-2006) of Dominica?
Give a very brief answer. 36.01. What is the difference between the highest and the lowest Production index(2004-2006) in Netherlands?
Make the answer very short. 10.61. What is the difference between the highest and the lowest Production index(2004-2006) in Poland?
Provide a short and direct response. 17.29. What is the difference between the highest and the lowest Production index(2004-2006) of St. Lucia?
Your answer should be very brief. 78.74. 